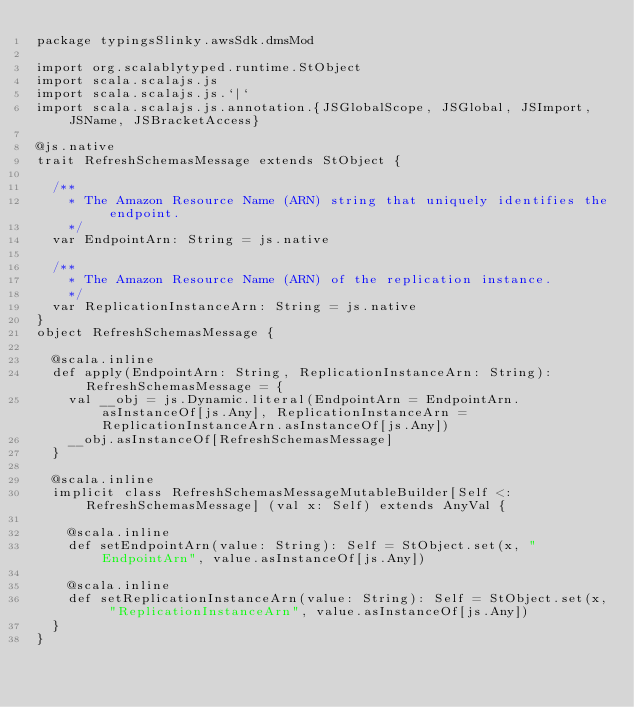Convert code to text. <code><loc_0><loc_0><loc_500><loc_500><_Scala_>package typingsSlinky.awsSdk.dmsMod

import org.scalablytyped.runtime.StObject
import scala.scalajs.js
import scala.scalajs.js.`|`
import scala.scalajs.js.annotation.{JSGlobalScope, JSGlobal, JSImport, JSName, JSBracketAccess}

@js.native
trait RefreshSchemasMessage extends StObject {
  
  /**
    * The Amazon Resource Name (ARN) string that uniquely identifies the endpoint.
    */
  var EndpointArn: String = js.native
  
  /**
    * The Amazon Resource Name (ARN) of the replication instance.
    */
  var ReplicationInstanceArn: String = js.native
}
object RefreshSchemasMessage {
  
  @scala.inline
  def apply(EndpointArn: String, ReplicationInstanceArn: String): RefreshSchemasMessage = {
    val __obj = js.Dynamic.literal(EndpointArn = EndpointArn.asInstanceOf[js.Any], ReplicationInstanceArn = ReplicationInstanceArn.asInstanceOf[js.Any])
    __obj.asInstanceOf[RefreshSchemasMessage]
  }
  
  @scala.inline
  implicit class RefreshSchemasMessageMutableBuilder[Self <: RefreshSchemasMessage] (val x: Self) extends AnyVal {
    
    @scala.inline
    def setEndpointArn(value: String): Self = StObject.set(x, "EndpointArn", value.asInstanceOf[js.Any])
    
    @scala.inline
    def setReplicationInstanceArn(value: String): Self = StObject.set(x, "ReplicationInstanceArn", value.asInstanceOf[js.Any])
  }
}
</code> 